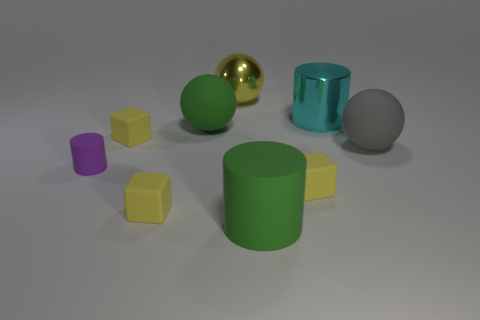Subtract all yellow cubes. How many were subtracted if there are1yellow cubes left? 2 Add 1 small purple things. How many objects exist? 10 Subtract all balls. How many objects are left? 6 Subtract all tiny rubber objects. Subtract all small purple cylinders. How many objects are left? 4 Add 2 small things. How many small things are left? 6 Add 4 green balls. How many green balls exist? 5 Subtract 0 gray blocks. How many objects are left? 9 